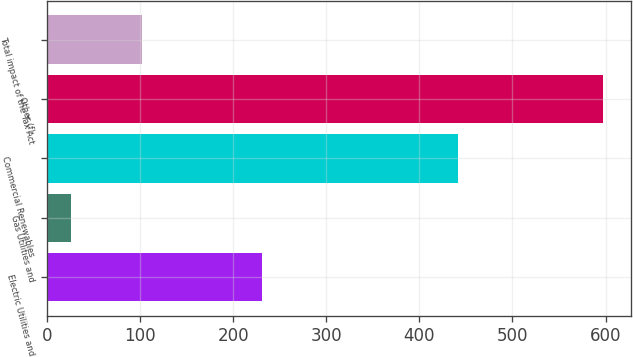<chart> <loc_0><loc_0><loc_500><loc_500><bar_chart><fcel>Electric Utilities and<fcel>Gas Utilities and<fcel>Commercial Renewables<fcel>Other (f)<fcel>Total impact of the Tax Act<nl><fcel>231<fcel>26<fcel>442<fcel>597<fcel>102<nl></chart> 